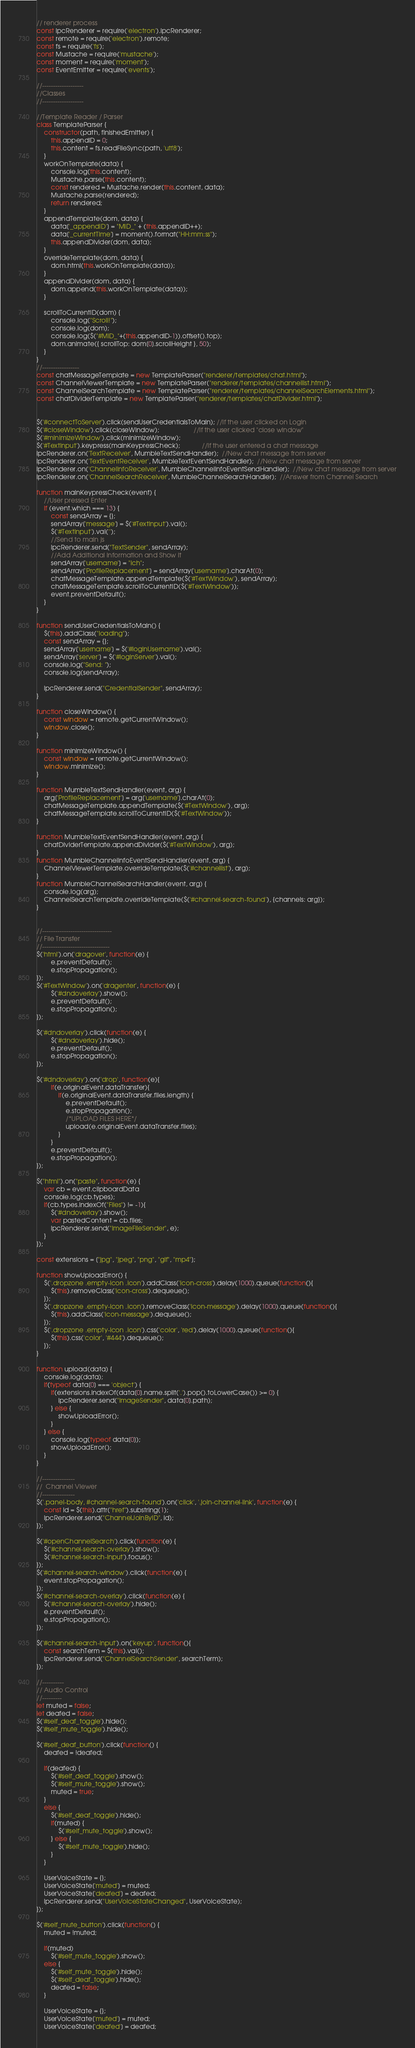Convert code to text. <code><loc_0><loc_0><loc_500><loc_500><_JavaScript_>// renderer process
const ipcRenderer = require('electron').ipcRenderer;
const remote = require('electron').remote;
const fs = require('fs');
const Mustache = require('mustache');
const moment = require('moment');
const EventEmitter = require('events');

//-------------------
//Classes
//-------------------

//Template Reader / Parser
class TemplateParser {
    constructor(path, finishedEmitter) {
        this.appendID = 0;
        this.content = fs.readFileSync(path, 'utf8');
    }   
    workOnTemplate(data) {
        console.log(this.content);
        Mustache.parse(this.content);
        const rendered = Mustache.render(this.content, data);
        Mustache.parse(rendered);  
        return rendered;
    }
    appendTemplate(dom, data) {
        data['_appendID'] = "MID_" + (this.appendID++);
        data['_currentTime'] = moment().format("HH:mm:ss");
        this.appendDivider(dom, data);
    }
    overrideTemplate(dom, data) {
        dom.html(this.workOnTemplate(data));
    }
    appendDivider(dom, data) { 
        dom.append(this.workOnTemplate(data));
    }

    scrollToCurrentID(dom) {
        console.log("Scroll!");
        console.log(dom);
        console.log($("#MID_"+(this.appendID-1)).offset().top);
        dom.animate({ scrollTop: dom[0].scrollHeight }, 50);    
    }
}
//-----------------
const chatMessageTemplate = new TemplateParser("renderer/templates/chat.html");
const ChannelViewerTemplate = new TemplateParser("renderer/templates/channellist.html");
const ChannelSearchTemplate = new TemplateParser("renderer/templates/channelSearchElements.html");
const chatDividerTemplate = new TemplateParser("renderer/templates/chatDivider.html");


$('#connectToServer').click(sendUserCredentialsToMain); //If the user clicked on Login
$('#closeWindow').click(closeWindow);                   //If the user clicked "close window"
$('#minimizeWindow').click(minimizeWindow);       
$('#TextInput').keypress(mainKeypressCheck);            //If the user entered a chat message
ipcRenderer.on('TextReceiver', MumbleTextSendHandler);  //New chat message from server
ipcRenderer.on('TextEventReceiver', MumbleTextEventSendHandler);  //New chat message from server
ipcRenderer.on('ChannelInfoReceiver', MumbleChannelInfoEventSendHandler);  //New chat message from server
ipcRenderer.on('ChannelSearchReceiver', MumbleChannelSearchHandler);  //Answer from Channel Search

function mainKeypressCheck(event) {
    //User pressed Enter
    if (event.which === 13) {
        const sendArray = {};
        sendArray['message'] = $('#TextInput').val();
        $('#TextInput').val('');
        //Send to main js
        ipcRenderer.send("TextSender", sendArray);
        //Add Additional Information and Show it
        sendArray['username'] = "Ich";
        sendArray['ProfileReplacement'] = sendArray['username'].charAt(0);
        chatMessageTemplate.appendTemplate($('#TextWindow'), sendArray);
        chatMessageTemplate.scrollToCurrentID($('#TextWindow'));
        event.preventDefault();  
    }
}

function sendUserCredentialsToMain() {
    $(this).addClass("loading");
    const sendArray = {};
    sendArray['username'] = $('#loginUsername').val();
    sendArray['server'] = $('#loginServer').val();
    console.log("Send: ");
    console.log(sendArray);

    ipcRenderer.send("CredentialSender", sendArray);
}

function closeWindow() {
    const window = remote.getCurrentWindow();
    window.close();
}

function minimizeWindow() {
    const window = remote.getCurrentWindow();
    window.minimize();
}

function MumbleTextSendHandler(event, arg) {
    arg['ProfileReplacement'] = arg['username'].charAt(0);
    chatMessageTemplate.appendTemplate($('#TextWindow'), arg);
    chatMessageTemplate.scrollToCurrentID($('#TextWindow'));
}

function MumbleTextEventSendHandler(event, arg) {
    chatDividerTemplate.appendDivider($('#TextWindow'), arg);
}
function MumbleChannelInfoEventSendHandler(event, arg) {
    ChannelViewerTemplate.overrideTemplate($('#channellist'), arg);
}
function MumbleChannelSearchHandler(event, arg) {
    console.log(arg);
    ChannelSearchTemplate.overrideTemplate($('#channel-search-found'), {channels: arg});
}


//--------------------------------
// File Transfer
//-------------------------------
$('html').on('dragover', function(e) {
        e.preventDefault();
        e.stopPropagation();
});
$('#TextWindow').on('dragenter', function(e) {
        $('#dndoverlay').show();
        e.preventDefault();
        e.stopPropagation();
});

$('#dndoverlay').click(function(e) {
        $('#dndoverlay').hide();
        e.preventDefault();
        e.stopPropagation();
});
  
$('#dndoverlay').on('drop', function(e){
        if(e.originalEvent.dataTransfer){
            if(e.originalEvent.dataTransfer.files.length) {
                e.preventDefault();
                e.stopPropagation();
                /*UPLOAD FILES HERE*/
                upload(e.originalEvent.dataTransfer.files);
            }  
        }
        e.preventDefault();
        e.stopPropagation();
});

$("html").on("paste", function(e) {
    var cb = event.clipboardData
    console.log(cb.types);
    if(cb.types.indexOf("Files") != -1){
        $('#dndoverlay').show();
        var pastedContent = cb.files;
        ipcRenderer.send("ImageFileSender", e);
    }
});

const extensions = ["jpg", "jpeg", "png", "gif", "mp4"];

function showUploadError() {
    $('.dropzone .empty-icon .icon').addClass('icon-cross').delay(1000).queue(function(){
        $(this).removeClass('icon-cross').dequeue();
    });
    $('.dropzone .empty-icon .icon').removeClass('icon-message').delay(1000).queue(function(){
        $(this).addClass('icon-message').dequeue();
    });
    $('.dropzone .empty-icon .icon').css('color', 'red').delay(1000).queue(function(){
        $(this).css('color', '#444').dequeue();
    });
}

function upload(data) {
    console.log(data);
    if(typeof data[0] === 'object') {
        if(extensions.indexOf(data[0].name.split('.').pop().toLowerCase()) >= 0) {
            ipcRenderer.send("ImageSender", data[0].path);
        } else {
            showUploadError();    
        }
    } else {
        console.log(typeof data[0]);
        showUploadError();
    }
}

//---------------
//  Channel Viewer
//---------------
$('.panel-body, #channel-search-found').on('click', '.join-channel-link', function(e) {
    const id = $(this).attr("href").substring(1);
    ipcRenderer.send("ChannelJoinByID", id);
});

$('#openChannelSearch').click(function(e) {
    $('#channel-search-overlay').show();
    $('#channel-search-input').focus();
});
$('#channel-search-window').click(function(e) {
    event.stopPropagation();
});
$('#channel-search-overlay').click(function(e) {
    $('#channel-search-overlay').hide();
    e.preventDefault();
    e.stopPropagation();
});

$('#channel-search-input').on('keyup', function(){
    const searchTerm = $(this).val();
    ipcRenderer.send("ChannelSearchSender", searchTerm);
});

//----------
// Audio Control
//---------
let muted = false;
let deafed = false;
$('#self_deaf_toggle').hide();
$('#self_mute_toggle').hide();

$('#self_deaf_button').click(function() {
    deafed = !deafed;

    if(deafed) {
        $('#self_deaf_toggle').show();
        $('#self_mute_toggle').show();
        muted = true;
    }
    else {
        $('#self_deaf_toggle').hide();
        if(muted) {
            $('#self_mute_toggle').show();
        } else {
            $('#self_mute_toggle').hide();
        }
    }
    
    UserVoiceState = {};
    UserVoiceState['muted'] = muted;
    UserVoiceState['deafed'] = deafed;
    ipcRenderer.send("UserVoiceStateChanged", UserVoiceState);
});

$('#self_mute_button').click(function() {
    muted = !muted;

    if(muted)
        $('#self_mute_toggle').show();
    else {
        $('#self_mute_toggle').hide();
        $('#self_deaf_toggle').hide();
        deafed = false;
    }

    UserVoiceState = {};
    UserVoiceState['muted'] = muted;
    UserVoiceState['deafed'] = deafed;</code> 